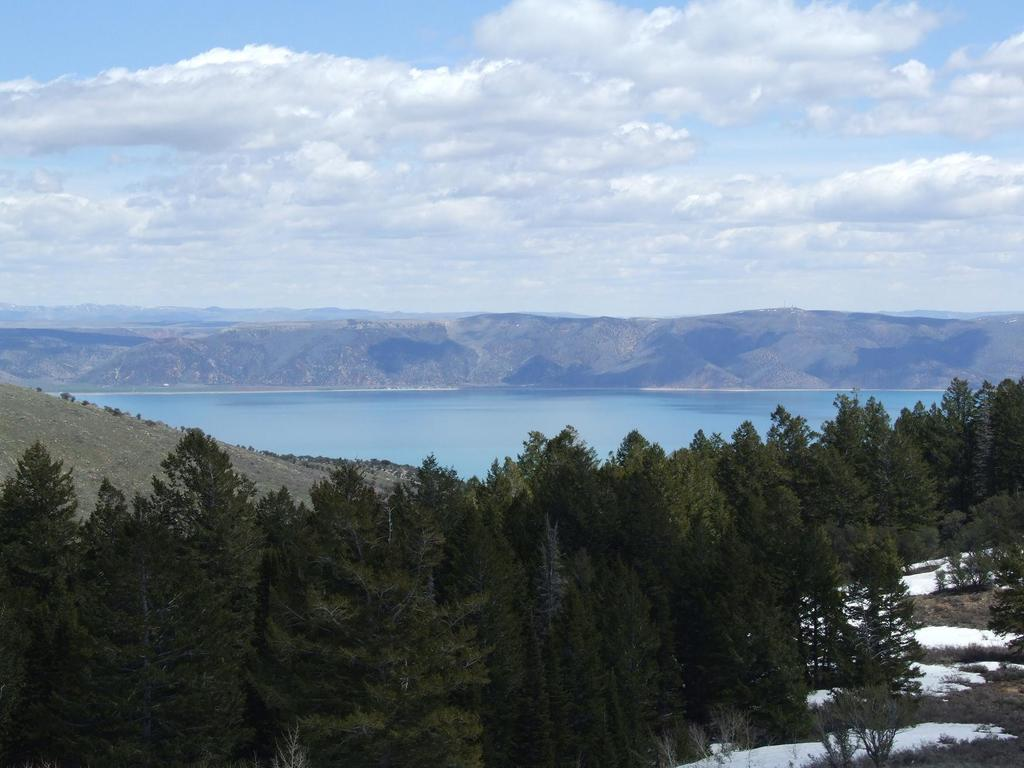What type of vegetation is at the bottom of the image? There are trees at the bottom of the image. What can be seen in the middle of the image? There appears to be water in the middle of the image. What is visible at the top of the image? The sky is visible at the top of the image. Can you tell me how many lawyers are depicted in the image? There are no lawyers present in the image. Are there any icicles hanging from the trees in the image? There is no mention of icicles in the provided facts, and therefore we cannot determine if any are present in the image. 